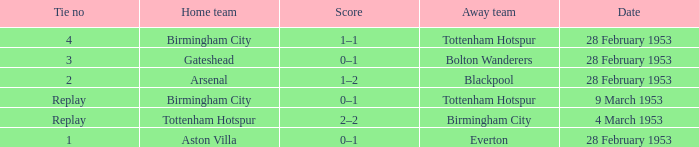Which Score has a Home team of aston villa? 0–1. 